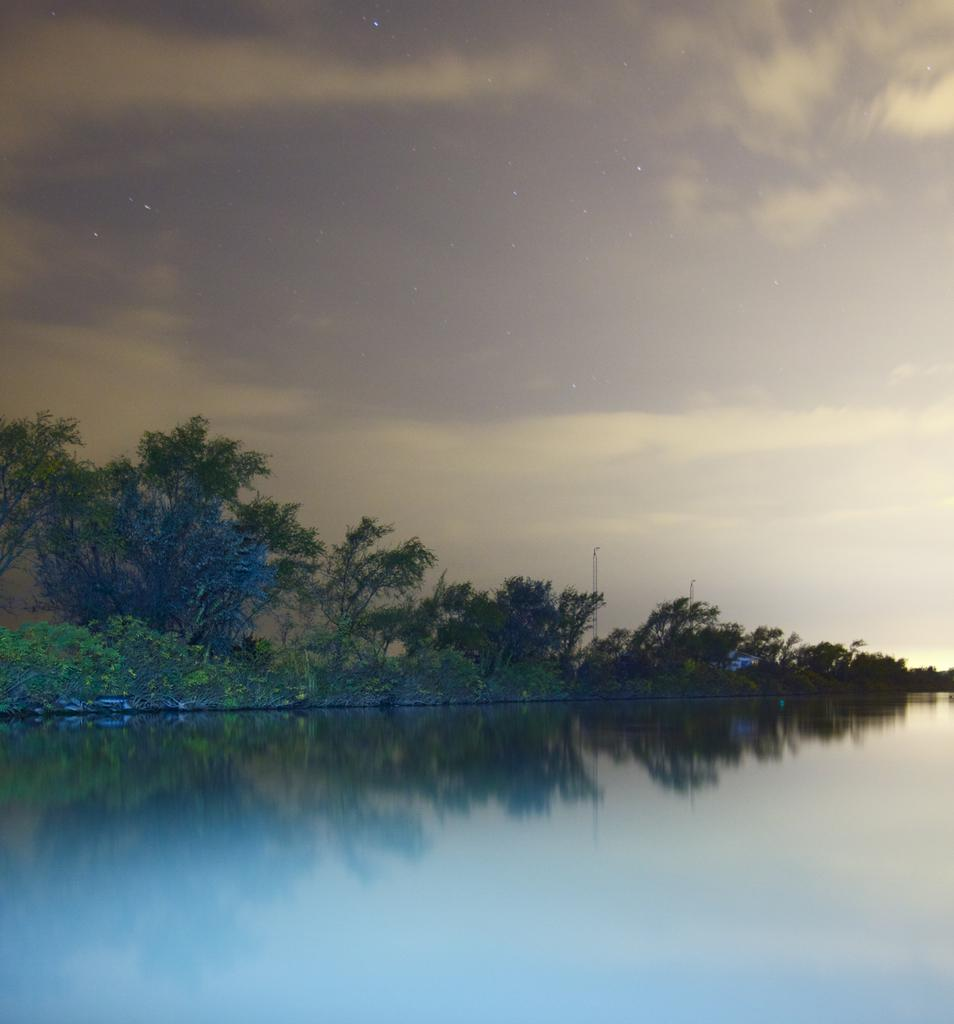What is the primary element visible in the image? There is water in the image. What type of vegetation can be seen in the image? There are trees and grass in the image. What part of the natural environment is visible in the image? The sky is visible in the image. What type of account is being discussed in the image? There is no account being discussed in the image; it features water, trees, grass, and the sky. 